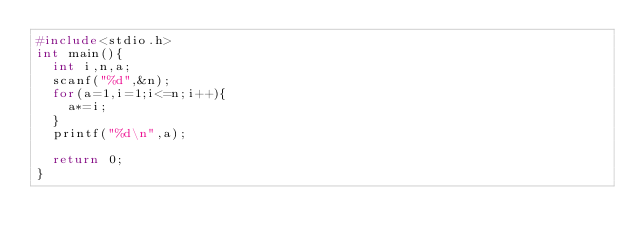<code> <loc_0><loc_0><loc_500><loc_500><_C_>#include<stdio.h>
int main(){
	int i,n,a;
	scanf("%d",&n);
	for(a=1,i=1;i<=n;i++){
		a*=i;
	}
	printf("%d\n",a);
	
	return 0;
}</code> 